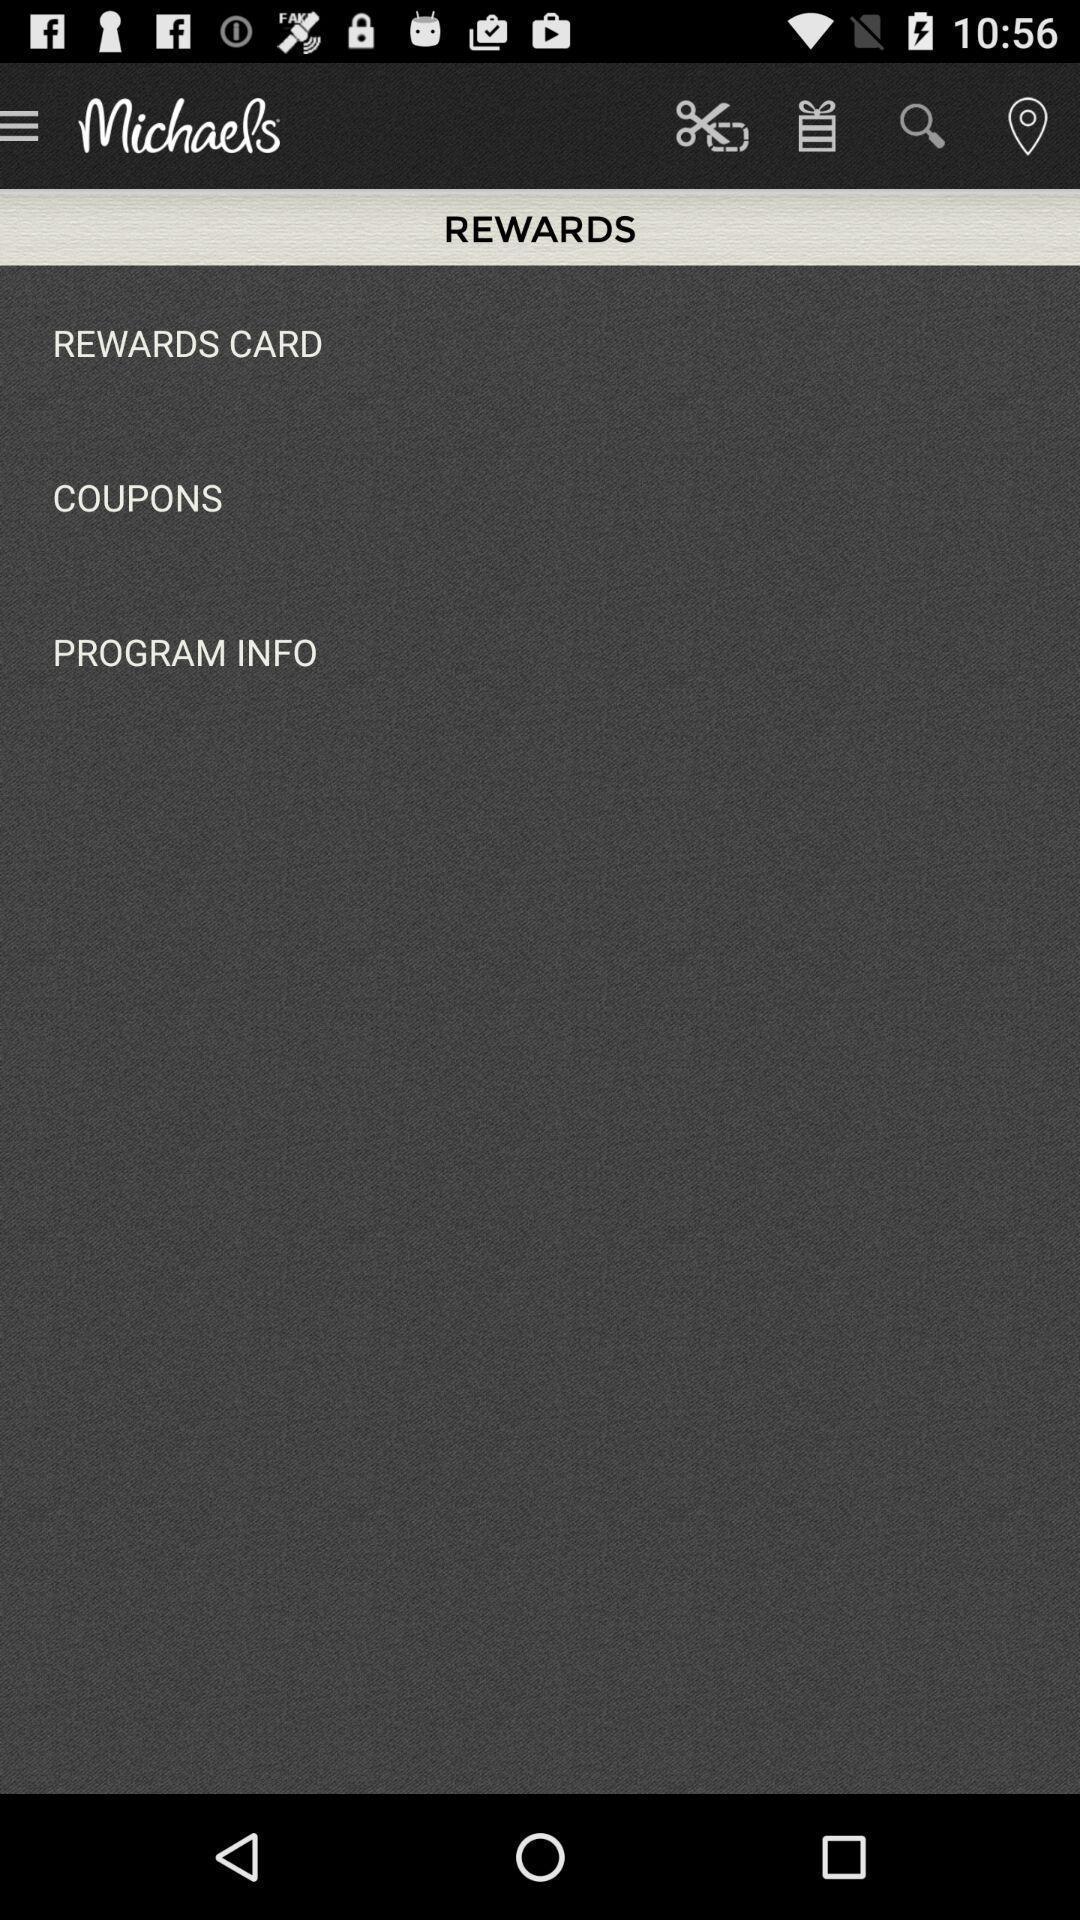Tell me what you see in this picture. Screen displaying the rewards page. 